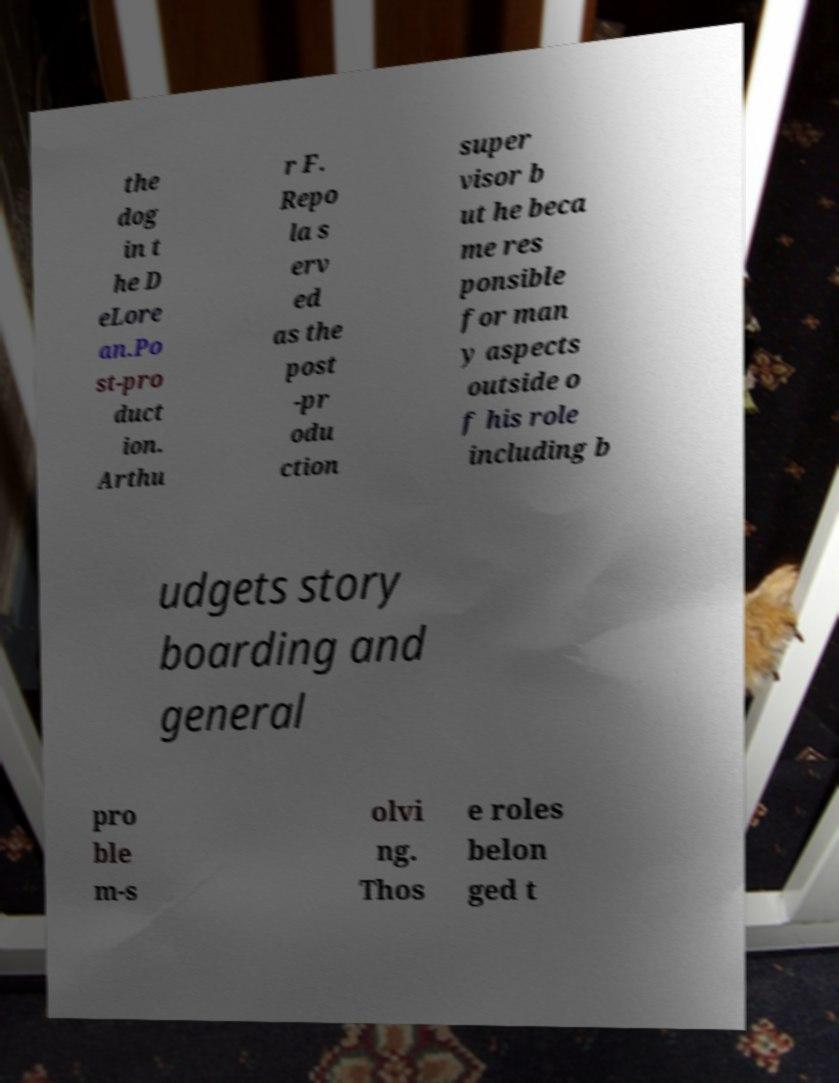Could you assist in decoding the text presented in this image and type it out clearly? the dog in t he D eLore an.Po st-pro duct ion. Arthu r F. Repo la s erv ed as the post -pr odu ction super visor b ut he beca me res ponsible for man y aspects outside o f his role including b udgets story boarding and general pro ble m-s olvi ng. Thos e roles belon ged t 